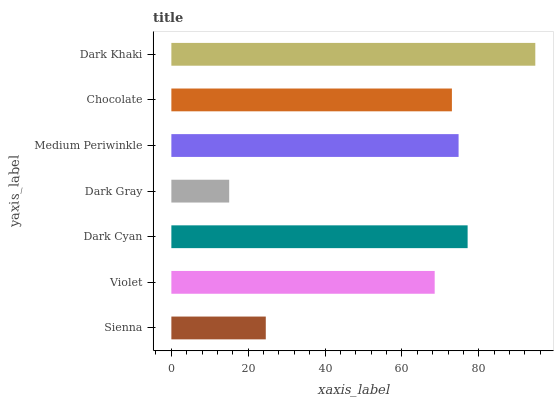Is Dark Gray the minimum?
Answer yes or no. Yes. Is Dark Khaki the maximum?
Answer yes or no. Yes. Is Violet the minimum?
Answer yes or no. No. Is Violet the maximum?
Answer yes or no. No. Is Violet greater than Sienna?
Answer yes or no. Yes. Is Sienna less than Violet?
Answer yes or no. Yes. Is Sienna greater than Violet?
Answer yes or no. No. Is Violet less than Sienna?
Answer yes or no. No. Is Chocolate the high median?
Answer yes or no. Yes. Is Chocolate the low median?
Answer yes or no. Yes. Is Dark Khaki the high median?
Answer yes or no. No. Is Dark Gray the low median?
Answer yes or no. No. 